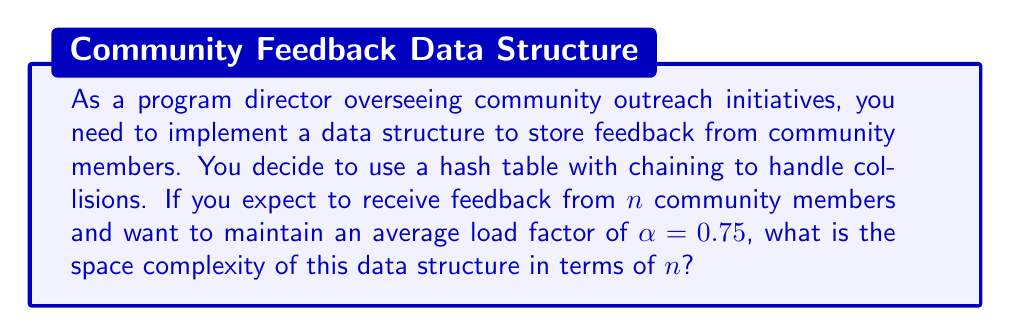What is the answer to this math problem? To solve this problem, let's break it down step by step:

1) In a hash table with chaining, we have an array of linked lists. The space complexity consists of two parts:
   a) The space for the array
   b) The space for the linked lists (chains)

2) Let $m$ be the number of buckets in the hash table. We know that:
   $$\alpha = \frac{n}{m}$$
   where $\alpha$ is the load factor, $n$ is the number of items, and $m$ is the number of buckets.

3) We're given that $\alpha = 0.75$, so:
   $$0.75 = \frac{n}{m}$$

4) Solving for $m$:
   $$m = \frac{n}{0.75} = \frac{4n}{3}$$

5) The space for the array of buckets is therefore $O(m) = O(\frac{4n}{3}) = O(n)$.

6) For the chains, in the worst case, all $n$ items could be in the same bucket, requiring $O(n)$ space.

7) However, on average, each bucket will contain $\alpha = 0.75$ items, so the total space for all chains is still $O(n)$.

8) Combining the space for the array and the chains, we get:
   $O(n) + O(n) = O(n)$

Therefore, the overall space complexity is $O(n)$.
Answer: $O(n)$ 